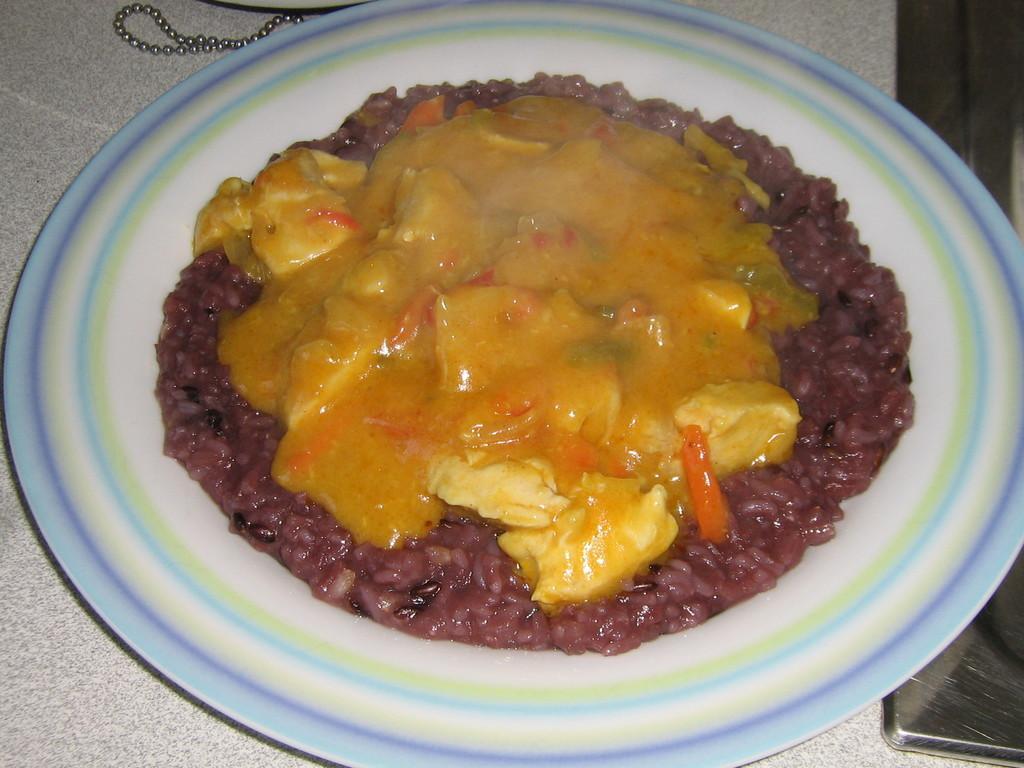Please provide a concise description of this image. In the image there is some cooked food item served on a plate. 